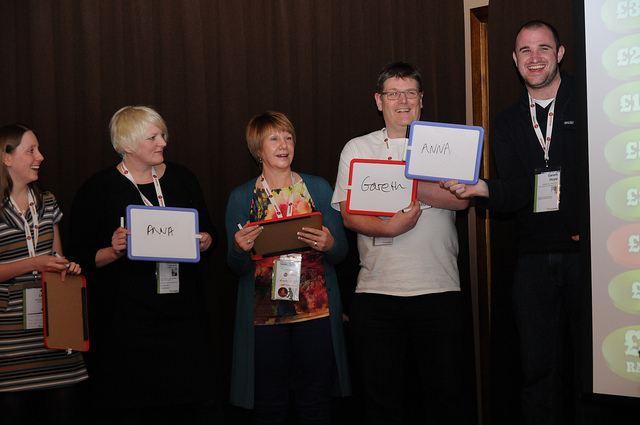<image>Which country was hosting the event? It is uncertain which country was hosting the event. It could be the US or UK. Which country was hosting the event? I don't know which country was hosting the event. It can be either the US, UK, or America. 